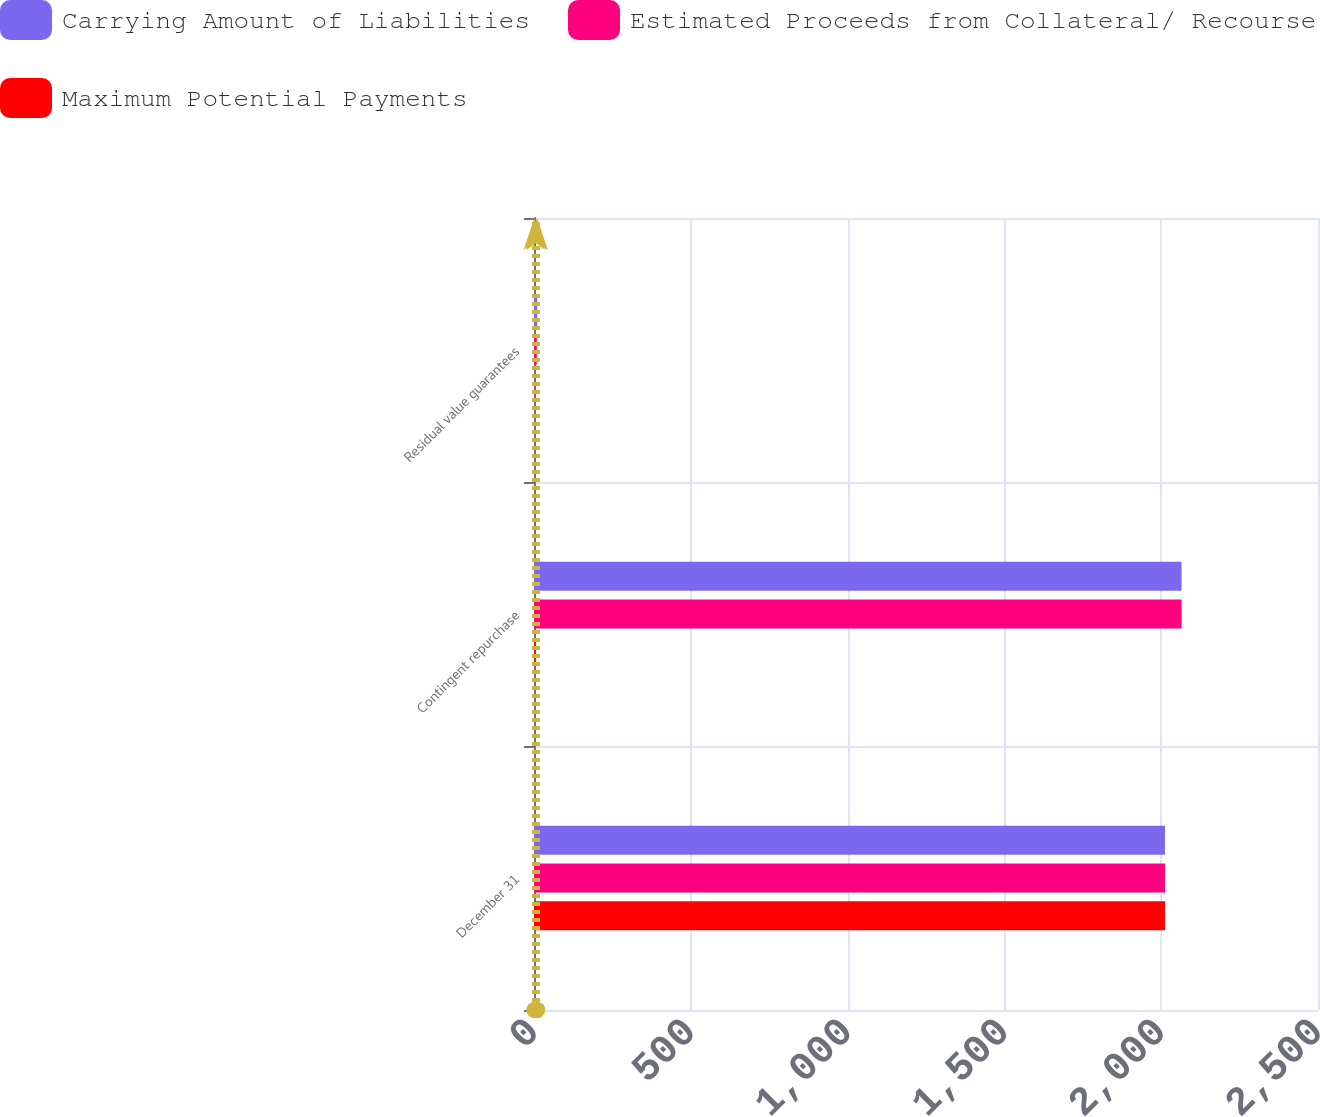<chart> <loc_0><loc_0><loc_500><loc_500><stacked_bar_chart><ecel><fcel>December 31<fcel>Contingent repurchase<fcel>Residual value guarantees<nl><fcel>Carrying Amount of Liabilities<fcel>2012<fcel>2065<fcel>10<nl><fcel>Estimated Proceeds from Collateral/ Recourse<fcel>2012<fcel>2065<fcel>9<nl><fcel>Maximum Potential Payments<fcel>2012<fcel>5<fcel>1<nl></chart> 